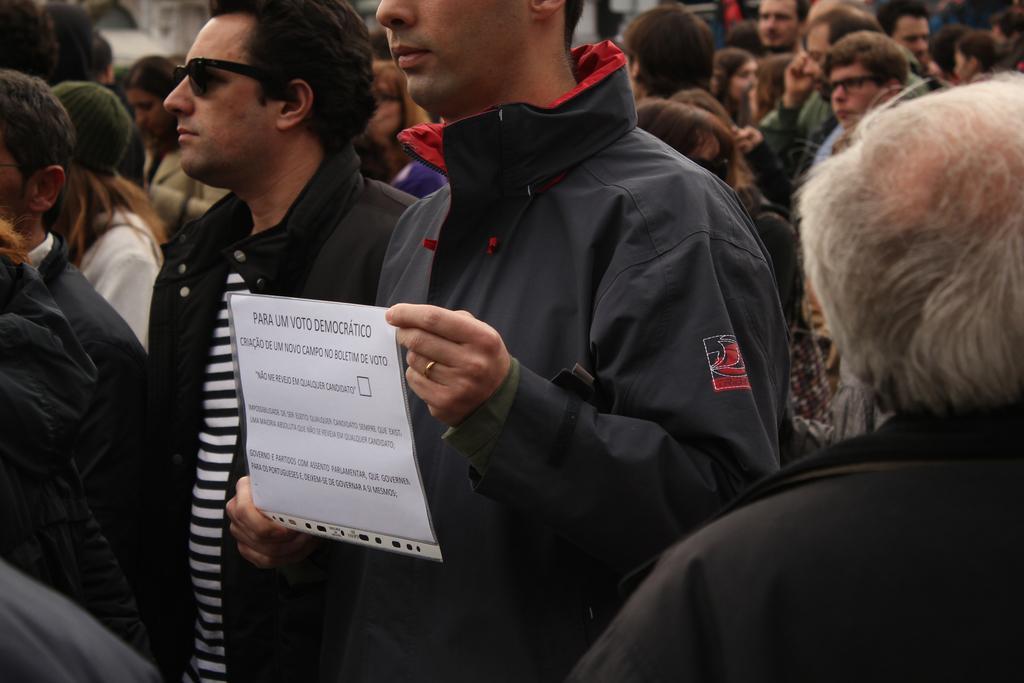Describe this image in one or two sentences. In this image I can see group of people. There is a person holding paper in his hands. 